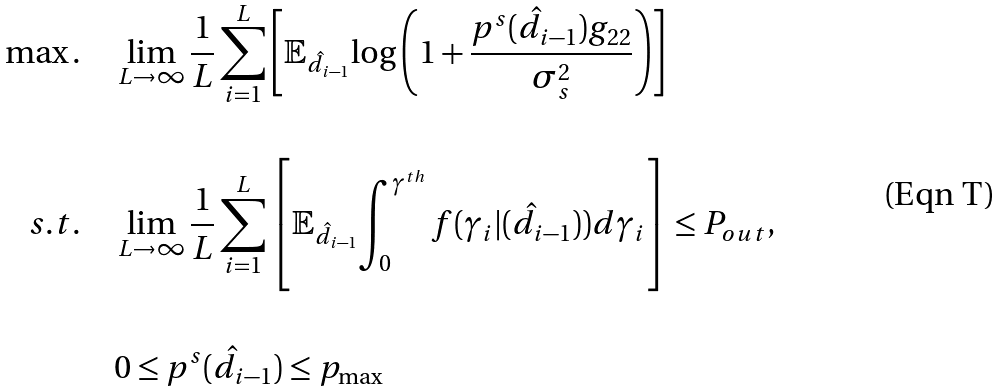Convert formula to latex. <formula><loc_0><loc_0><loc_500><loc_500>\max . \quad & \lim _ { L \rightarrow \infty } \frac { 1 } { L } \sum ^ { L } _ { i = 1 } \left [ \mathbb { E } _ { \hat { d } _ { i - 1 } } { \log \left ( 1 + \frac { p ^ { s } ( \hat { d } _ { i - 1 } ) g _ { 2 2 } } { \sigma _ { s } ^ { 2 } } \right ) } \right ] \\ \quad \\ s . t . \quad & \lim _ { L \rightarrow \infty } \frac { 1 } { L } \sum ^ { L } _ { i = 1 } \left [ \mathbb { E } _ { \hat { d } _ { i - 1 } } { \int _ { 0 } ^ { \gamma ^ { t h } } { f ( \gamma _ { i } | ( \hat { d } _ { i - 1 } ) ) d \gamma _ { i } } } \right ] \leq P _ { o u t } , \\ \quad \\ & 0 \leq p ^ { s } ( \hat { d } _ { i - 1 } ) \leq p _ { \max }</formula> 